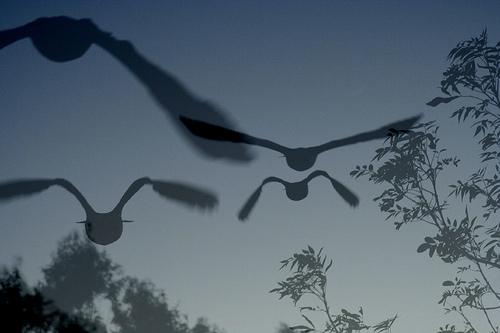Are clouds visible?
Quick response, please. No. Is it night time?
Quick response, please. Yes. Are these the same type of birds?
Concise answer only. Yes. Are these bird profiles?
Quick response, please. Yes. How many birds are in the picture?
Write a very short answer. 4. How many tree branches are there?
Keep it brief. 6. Do these animals eat fish?
Concise answer only. Yes. 